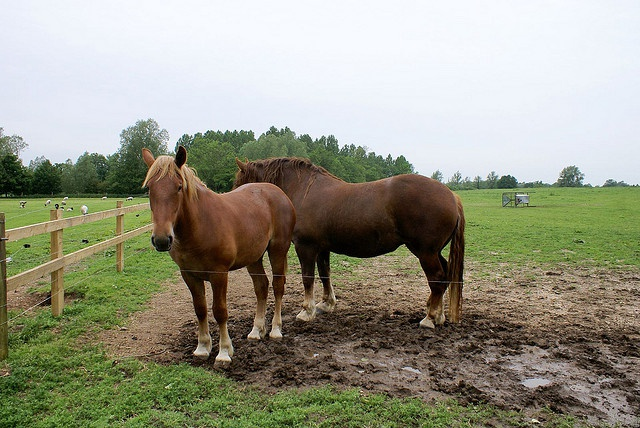Describe the objects in this image and their specific colors. I can see horse in lavender, black, maroon, and gray tones, horse in lavender, black, maroon, and gray tones, sheep in lavender, lightgray, olive, and darkgray tones, sheep in lavender, olive, darkgray, black, and white tones, and sheep in lavender, black, gray, and olive tones in this image. 